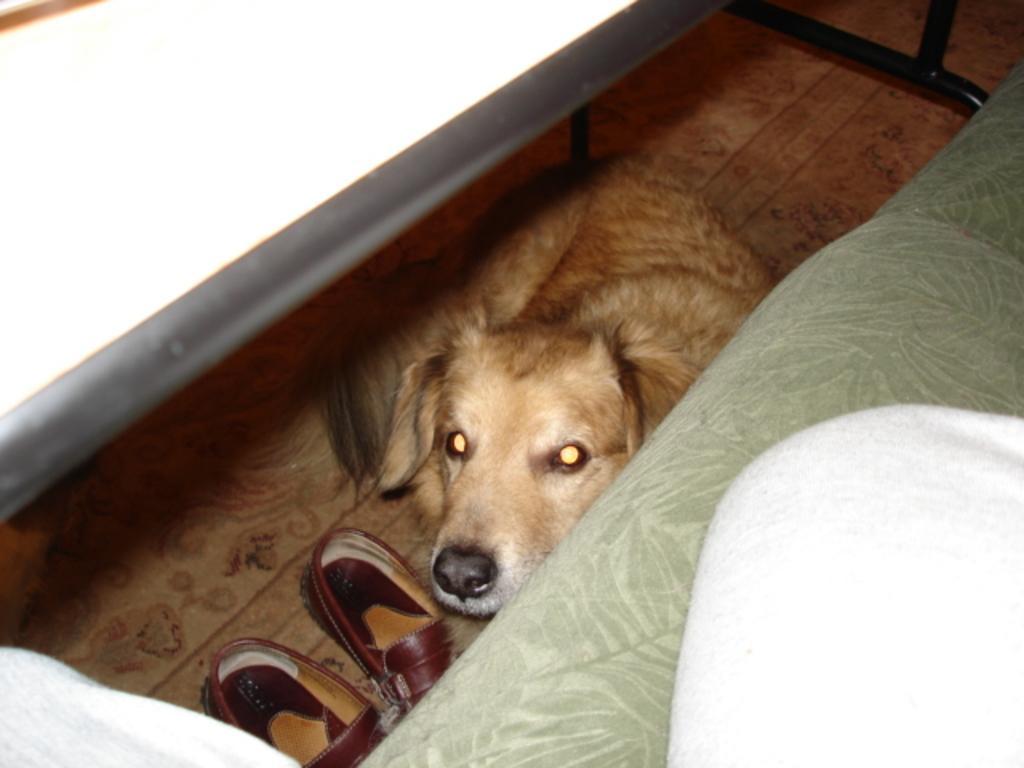Describe this image in one or two sentences. On the right side there is a bed on which I can see a white color bed sheet. Beside the bed there is a dog sitting on the floor, in front of it I can see the footwear. On the the top of the image I can see a white color table. 